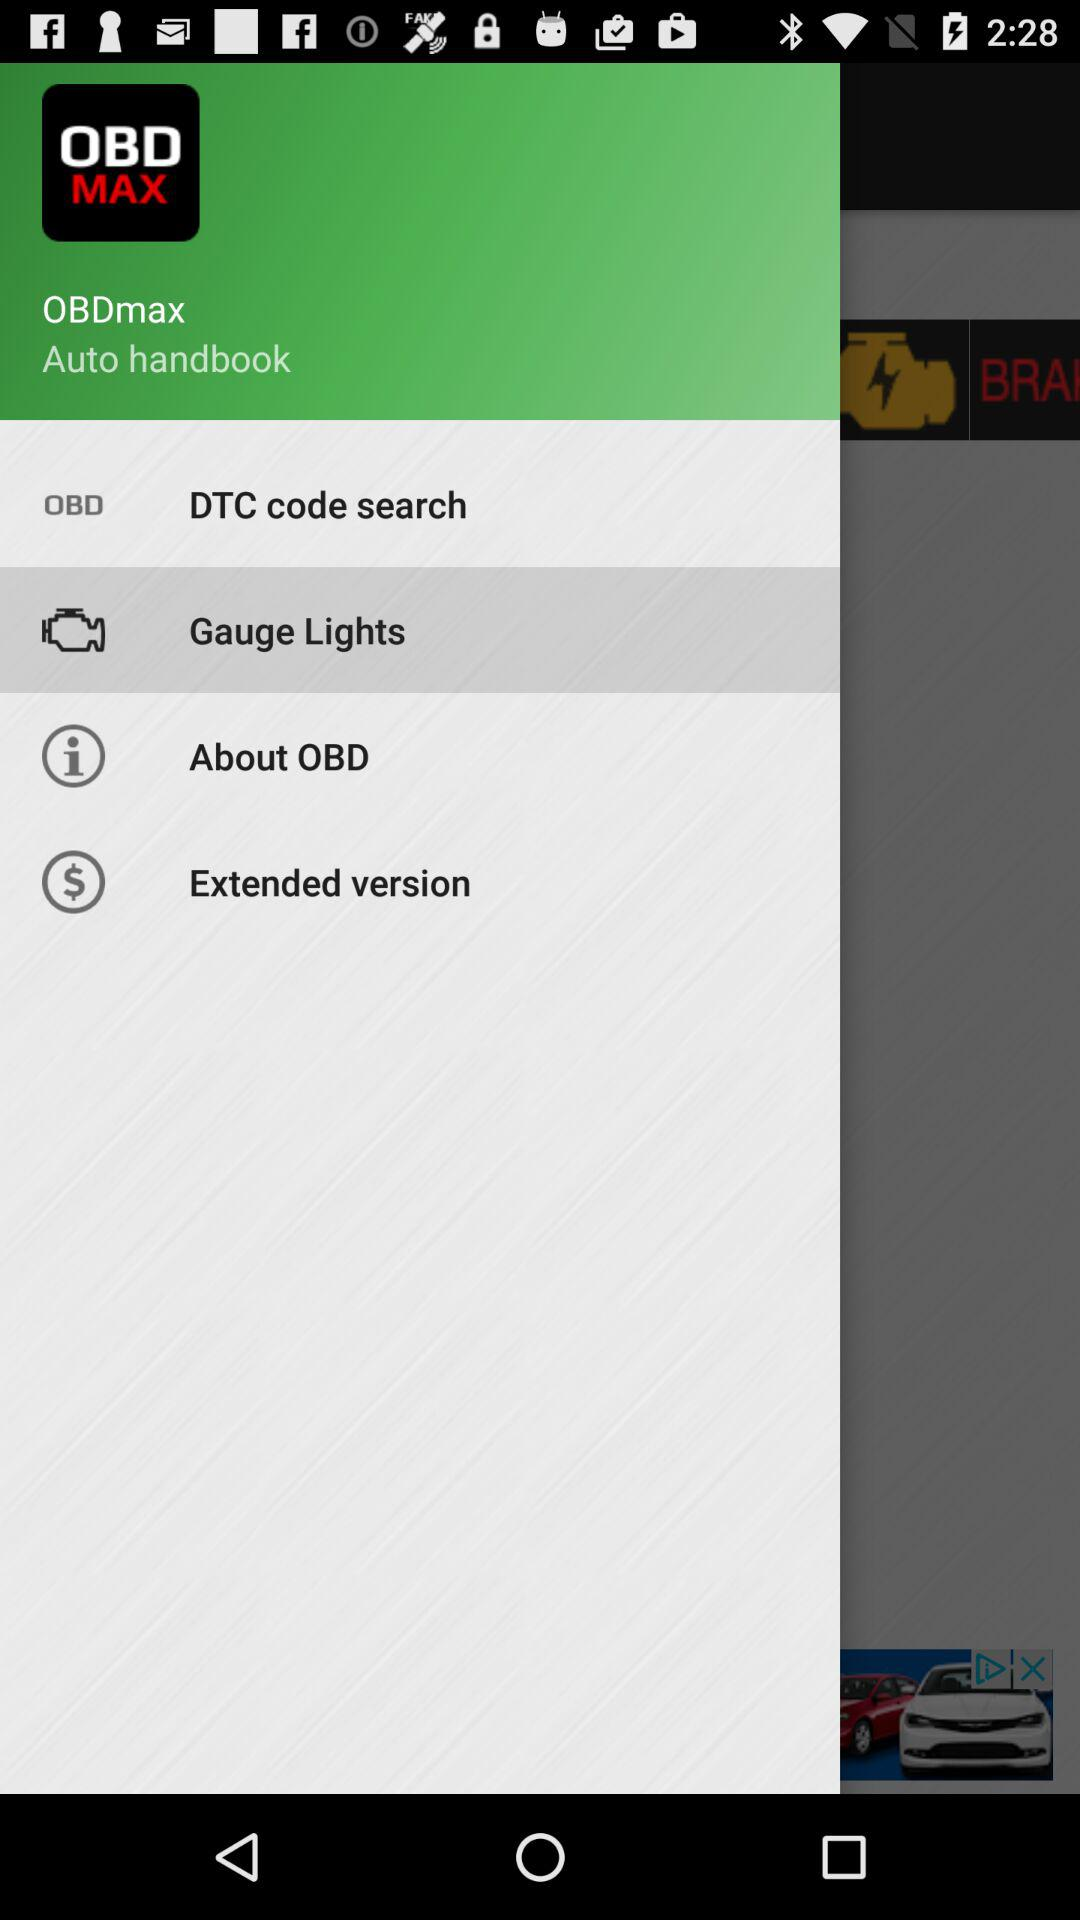Which item is selected on the screen? The selected item is "Gauge Lights". 